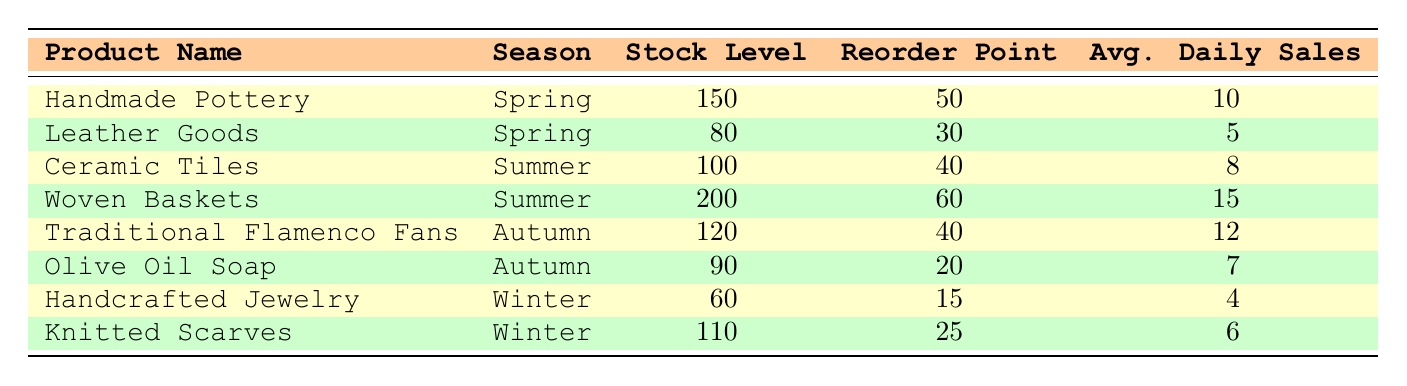What is the stock level for Handmade Pottery? The table shows that the stock level for Handmade Pottery is 150.
Answer: 150 What is the reorder point for Leather Goods? Referring to the table, the reorder point for Leather Goods is 30.
Answer: 30 Which product has the highest stock level in the Summer season? The table lists Woven Baskets as having the highest stock level in the Summer season at 200.
Answer: Woven Baskets Is the average daily sales for Knitted Scarves greater than that for Handcrafted Jewelry? The average daily sales for Knitted Scarves is 6, while for Handcrafted Jewelry it is 4. Since 6 is greater than 4, the answer is yes.
Answer: Yes What is the total stock level for products in the Autumn season? To find the total stock level for the Autumn season, we add the stock levels of Traditional Flamenco Fans (120) and Olive Oil Soap (90): 120 + 90 = 210.
Answer: 210 How many products have a stock level below their reorder point? The table indicates that both Leather Goods (80) and Handcrafted Jewelry (60) have stock levels below their reorder points (30 and 15, respectively), totaling 2 products.
Answer: 2 If the average daily sales for Ceramic Tiles and Woven Baskets are combined, what is the total? The average daily sales for Ceramic Tiles is 8 and for Woven Baskets is 15. Adding them gives 8 + 15 = 23.
Answer: 23 Is there a product in the Spring season with an average daily sales figure of 10? The table shows that Handmade Pottery has an average daily sales of 10, confirming that at least one product in Spring has this figure.
Answer: Yes What is the average stock level of products across all seasons? To find the average, first sum the stock levels: 150 + 80 + 100 + 200 + 120 + 90 + 60 + 110 = 1010. Divide by the number of products (8), resulting in an average stock level of 1010 / 8 = 126.25.
Answer: 126.25 